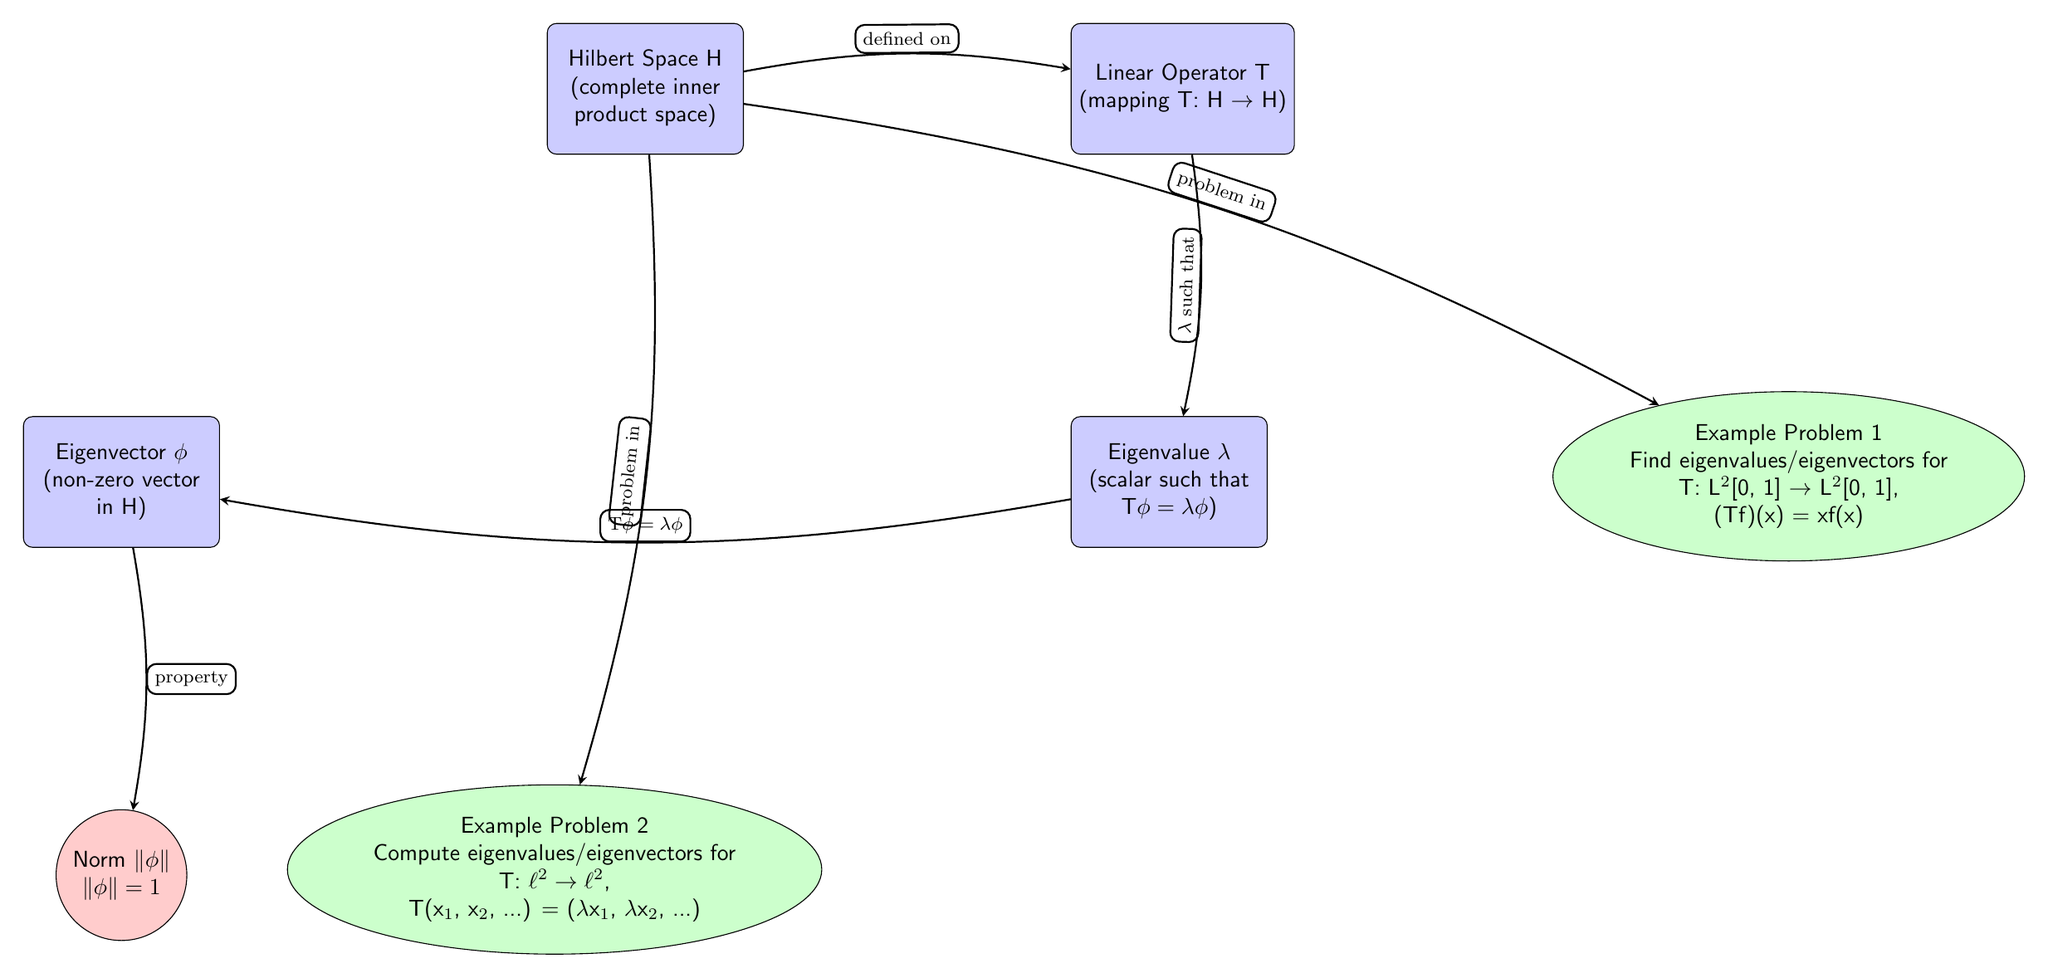What is the operator mapping in the diagram? The operator mapping is defined as T: H → H. This is a direct observation from the main node labeled "Linear Operator T" which specifies its action from one Hilbert space to another, or to itself.
Answer: T: H → H What is the relationship between the eigenvalue and the operator? The diagram indicates that the eigenvalue λ is such that Tφ = λφ, which implies that during the action of the operator T on the eigenvector φ, the result is the eigenvector scaled by the eigenvalue λ. This relationship is depicted by the directed edge from the eigenvalue node to the eigenvector node.
Answer: Tφ = λφ How many example problems are presented in the diagram? There are two example problems illustrated in the diagram, each defined in separate example nodes below the linear operator node.
Answer: 2 What type of space is described at the top of the diagram? The top node describes a Hilbert space, characterized as a complete inner product space. This is evident from the main node labeled "Hilbert Space H".
Answer: Hilbert Space H What is the purpose of the arrows in the diagram? The arrows in the diagram represent relationships and properties between different concepts such as the linear operator, eigenvalue, and eigenvector, showing how they are interconnected. Each arrow is labeled to indicate the nature of the relationship.
Answer: Relationships What transformation is performed by the operator T in Example Problem 1? In Example Problem 1, the operator T transforms a function f in L²[0, 1] by multiplying it by x, as indicated in the problem description within the example node.
Answer: Tf(x) = xf(x) What are the spaces involved in Example Problem 2? The spaces involved in Example Problem 2 are ℓ² to ℓ², which specifies the context of the linear operator and the types of sequences being considered for eigenvalues and eigenvectors.
Answer: ℓ² to ℓ² 